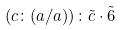Convert formula to latex. <formula><loc_0><loc_0><loc_500><loc_500>( c \colon ( a / a ) ) \colon \tilde { c } \cdot \tilde { 6 }</formula> 